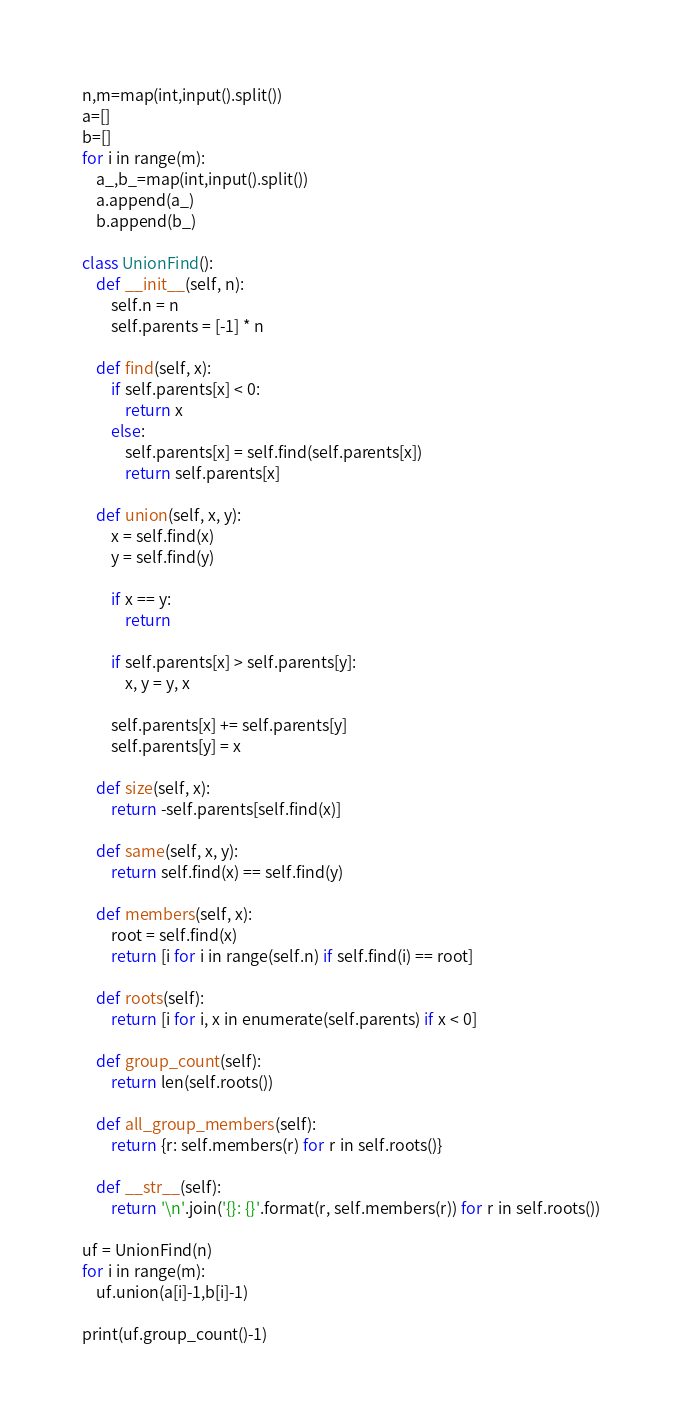Convert code to text. <code><loc_0><loc_0><loc_500><loc_500><_Python_>n,m=map(int,input().split())
a=[]
b=[]
for i in range(m):
    a_,b_=map(int,input().split())
    a.append(a_)
    b.append(b_)

class UnionFind():
    def __init__(self, n):
        self.n = n
        self.parents = [-1] * n

    def find(self, x):
        if self.parents[x] < 0:
            return x
        else:
            self.parents[x] = self.find(self.parents[x])
            return self.parents[x]

    def union(self, x, y):
        x = self.find(x)
        y = self.find(y)

        if x == y:
            return

        if self.parents[x] > self.parents[y]:
            x, y = y, x

        self.parents[x] += self.parents[y]
        self.parents[y] = x

    def size(self, x):
        return -self.parents[self.find(x)]

    def same(self, x, y):
        return self.find(x) == self.find(y)

    def members(self, x):
        root = self.find(x)
        return [i for i in range(self.n) if self.find(i) == root]

    def roots(self):
        return [i for i, x in enumerate(self.parents) if x < 0]

    def group_count(self):
        return len(self.roots())

    def all_group_members(self):
        return {r: self.members(r) for r in self.roots()}

    def __str__(self):
        return '\n'.join('{}: {}'.format(r, self.members(r)) for r in self.roots())

uf = UnionFind(n)
for i in range(m):
    uf.union(a[i]-1,b[i]-1)

print(uf.group_count()-1)</code> 